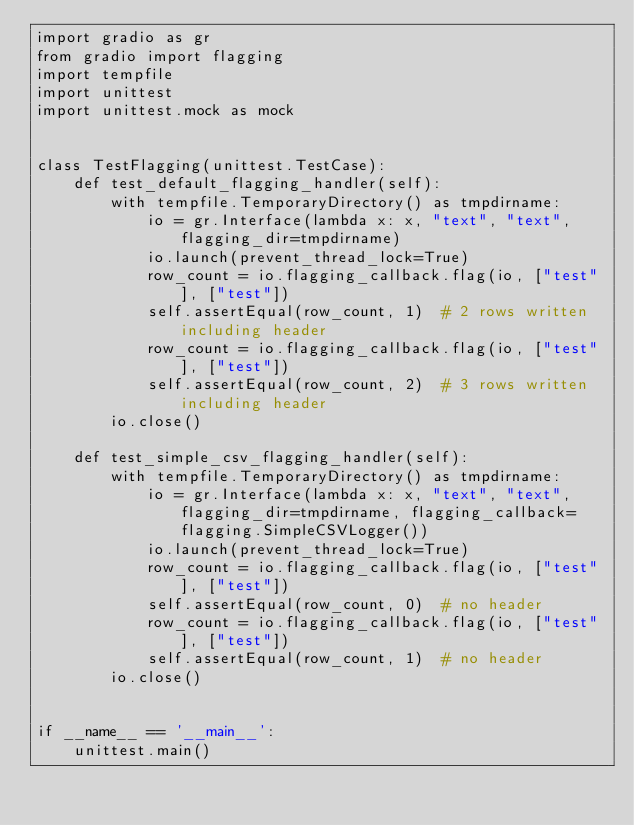Convert code to text. <code><loc_0><loc_0><loc_500><loc_500><_Python_>import gradio as gr
from gradio import flagging
import tempfile
import unittest
import unittest.mock as mock


class TestFlagging(unittest.TestCase):
    def test_default_flagging_handler(self):
        with tempfile.TemporaryDirectory() as tmpdirname:
            io = gr.Interface(lambda x: x, "text", "text", flagging_dir=tmpdirname)
            io.launch(prevent_thread_lock=True)
            row_count = io.flagging_callback.flag(io, ["test"], ["test"])
            self.assertEqual(row_count, 1)  # 2 rows written including header
            row_count = io.flagging_callback.flag(io, ["test"], ["test"])
            self.assertEqual(row_count, 2)  # 3 rows written including header
        io.close()

    def test_simple_csv_flagging_handler(self):
        with tempfile.TemporaryDirectory() as tmpdirname:
            io = gr.Interface(lambda x: x, "text", "text", flagging_dir=tmpdirname, flagging_callback=flagging.SimpleCSVLogger())
            io.launch(prevent_thread_lock=True)
            row_count = io.flagging_callback.flag(io, ["test"], ["test"])
            self.assertEqual(row_count, 0)  # no header
            row_count = io.flagging_callback.flag(io, ["test"], ["test"])
            self.assertEqual(row_count, 1)  # no header
        io.close()


if __name__ == '__main__':
    unittest.main()
</code> 